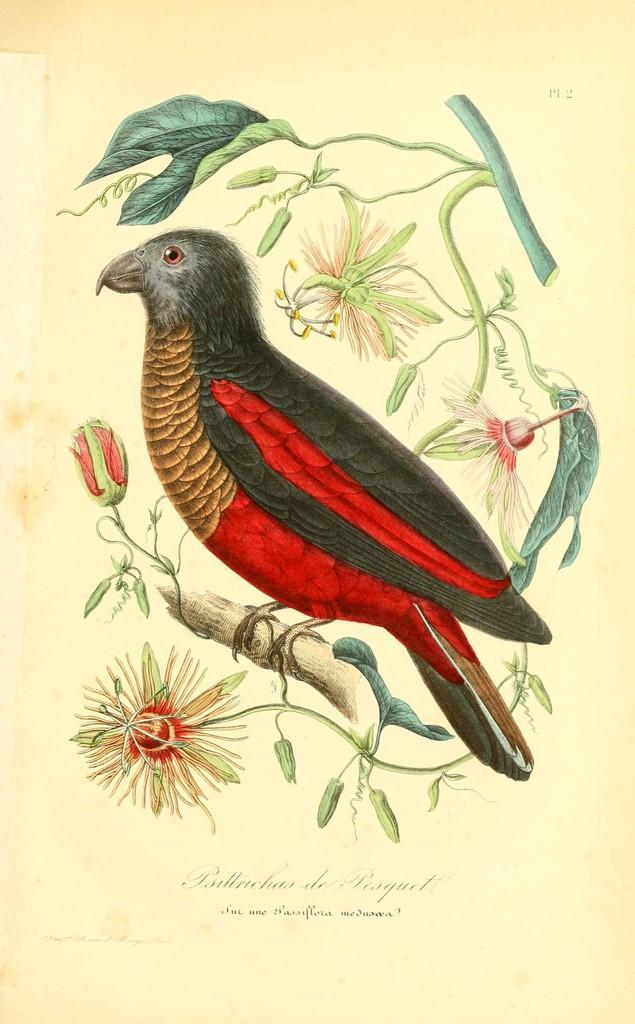What animal can be seen in the image? There is a bird sitting on a tree trunk in the image. What type of vegetation is present in the image? There are flowers on a plant in the image. What else can be seen on the wall in the image? There is a poster with writing on it in the image. What time is displayed on the clock in the image? There is no clock present in the image. What news headline can be read on the newspaper in the image? There is no newspaper present in the image. 